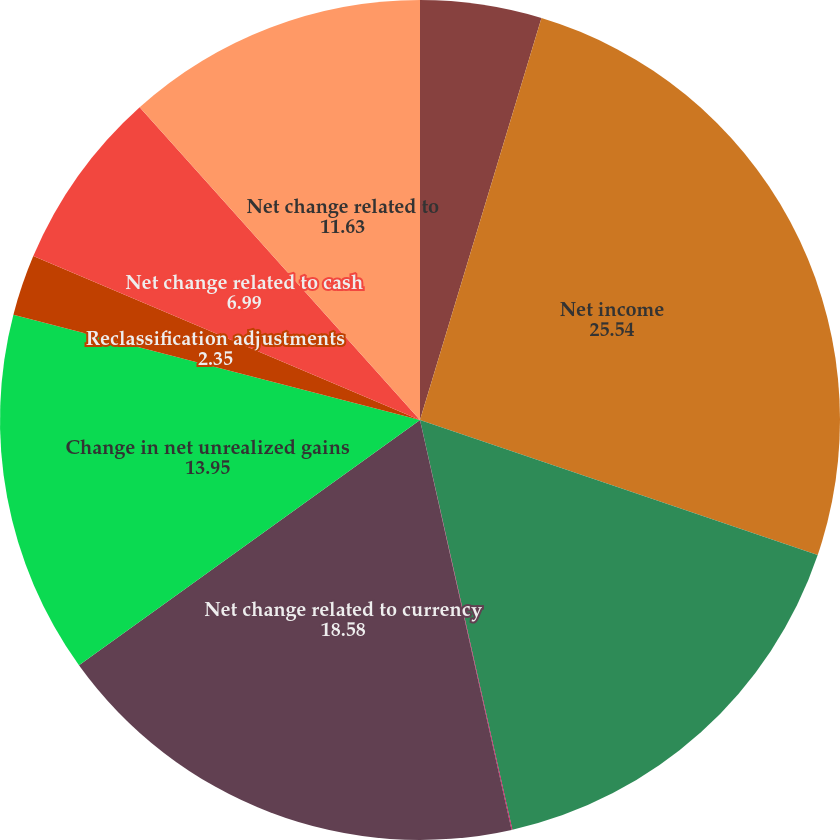<chart> <loc_0><loc_0><loc_500><loc_500><pie_chart><fcel>(In thousands)<fcel>Net income<fcel>Change in currency translation<fcel>Change in income tax benefit<fcel>Net change related to currency<fcel>Change in net unrealized gains<fcel>Reclassification adjustments<fcel>Net change related to cash<fcel>Net change related to<nl><fcel>4.67%<fcel>25.54%<fcel>16.26%<fcel>0.03%<fcel>18.58%<fcel>13.95%<fcel>2.35%<fcel>6.99%<fcel>11.63%<nl></chart> 